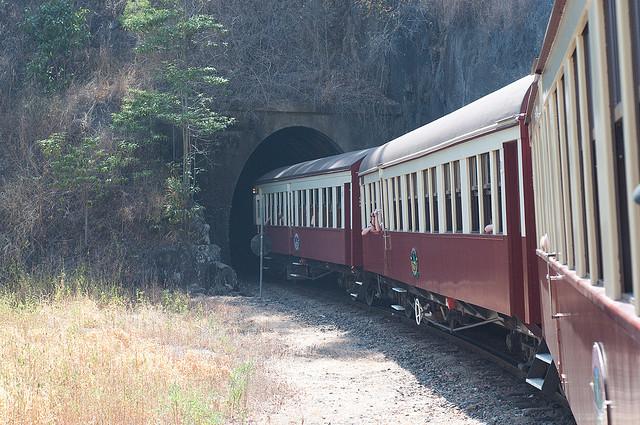Is the train going through a city?
Be succinct. No. Is the tunnel dark?
Write a very short answer. Yes. What color is the train?
Concise answer only. Red. What type of vehicle is this?
Concise answer only. Train. 